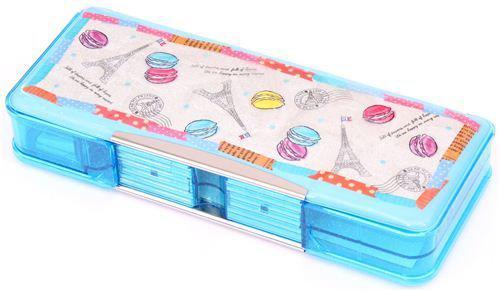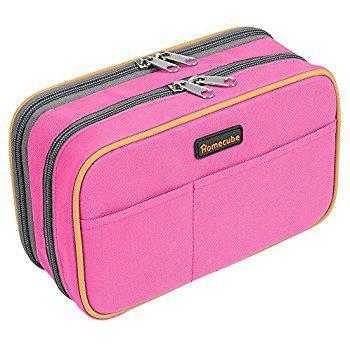The first image is the image on the left, the second image is the image on the right. Evaluate the accuracy of this statement regarding the images: "The image on the left shows a single pencil case that is closed.". Is it true? Answer yes or no. Yes. The first image is the image on the left, the second image is the image on the right. Considering the images on both sides, is "There are two open pencil cases." valid? Answer yes or no. No. 